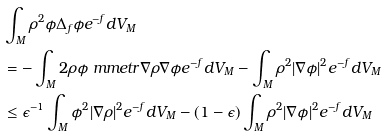Convert formula to latex. <formula><loc_0><loc_0><loc_500><loc_500>& \int _ { M } \rho ^ { 2 } \phi \Delta _ { f } \phi e ^ { - f } d V _ { M } \\ & = - \int _ { M } 2 \rho \phi \ m m e t r { \nabla \rho } { \nabla \phi } e ^ { - f } d V _ { M } - \int _ { M } \rho ^ { 2 } | \nabla \phi | ^ { 2 } e ^ { - f } d V _ { M } \\ & \leq \epsilon ^ { - 1 } \int _ { M } \phi ^ { 2 } | \nabla \rho | ^ { 2 } e ^ { - f } d V _ { M } - ( 1 - \epsilon ) \int _ { M } \rho ^ { 2 } | \nabla \phi | ^ { 2 } e ^ { - f } d V _ { M }</formula> 